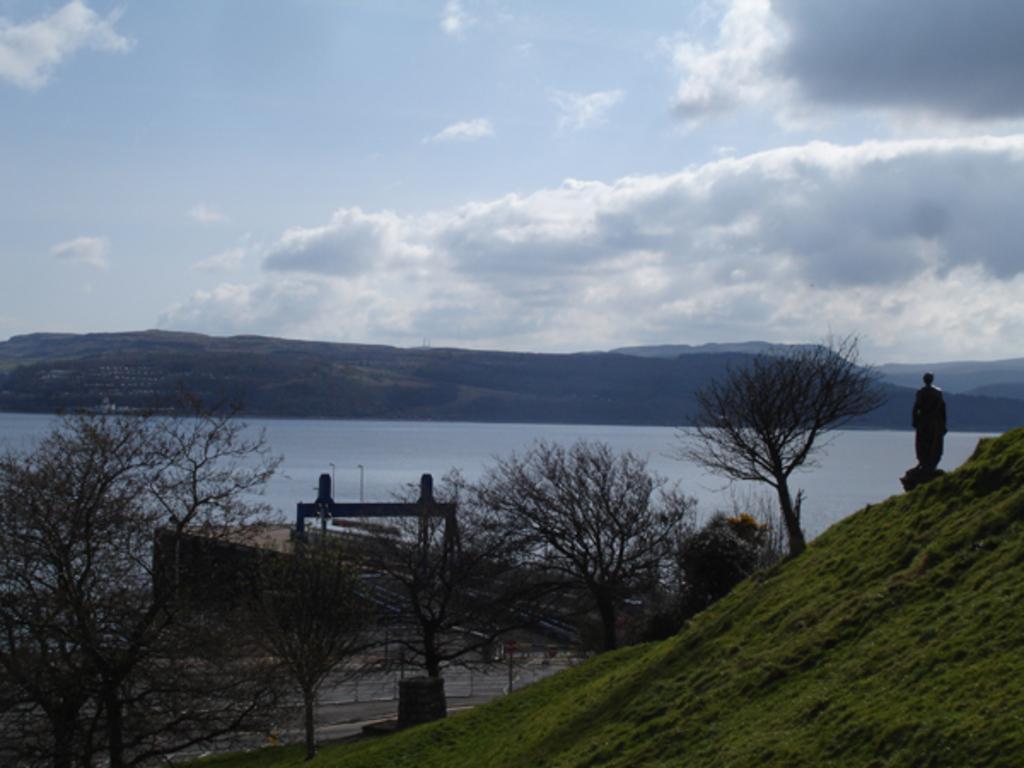Could you give a brief overview of what you see in this image? In this image I can see few dry trees, bridge, statue, mountains and the water. The sky is in blue and white color. 